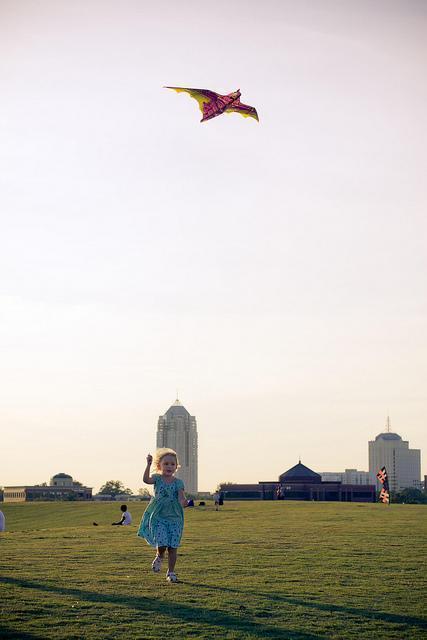How many people are in the picture?
Give a very brief answer. 3. How many people are there?
Give a very brief answer. 2. How many kites are there?
Give a very brief answer. 1. How many slices of pizza are visible?
Give a very brief answer. 0. 